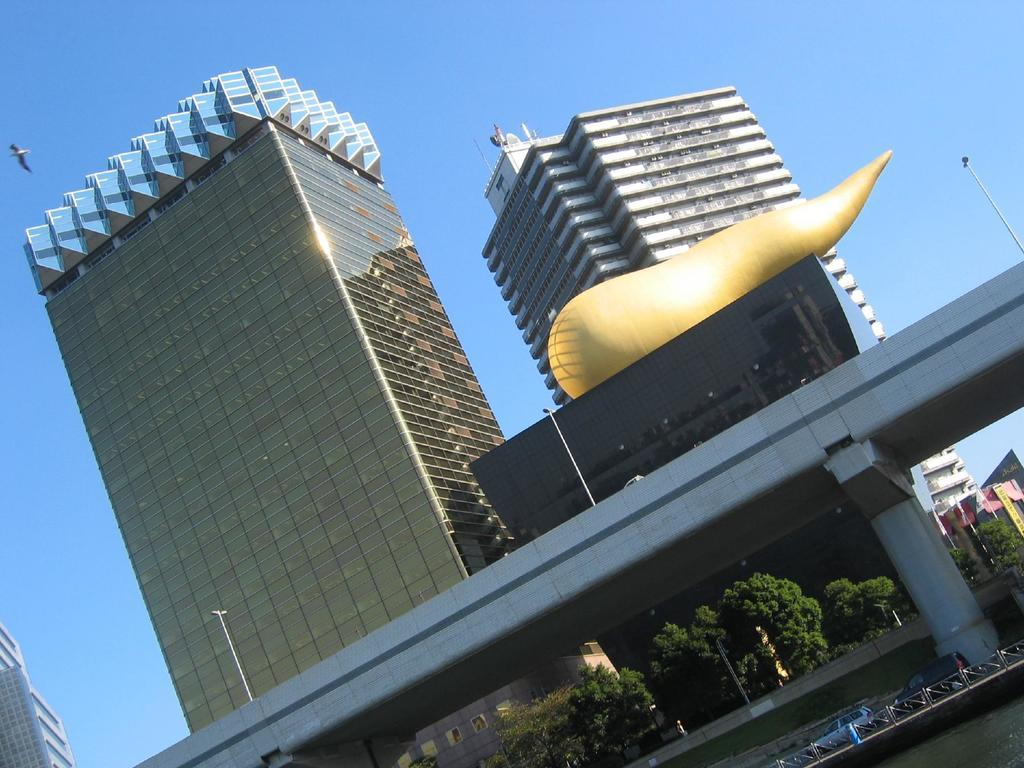What type of structures can be seen in the image? There are buildings in the image. What type of transportation infrastructure is present in the image? There is a bridge in the image. What type of vertical structures can be seen in the image? There are poles in the image. What type of natural elements can be seen in the image? There are trees in the image. What type of man-made objects can be seen in the image? There are vehicles in the image. What type of barrier can be seen in the image? There is a fence in the image. What part of the natural environment is visible in the background of the image? The sky is visible in the background of the image. Where is the lunchroom located in the image? There is no lunchroom present in the image. What type of loss is depicted in the image? There is no loss depicted in the image. 